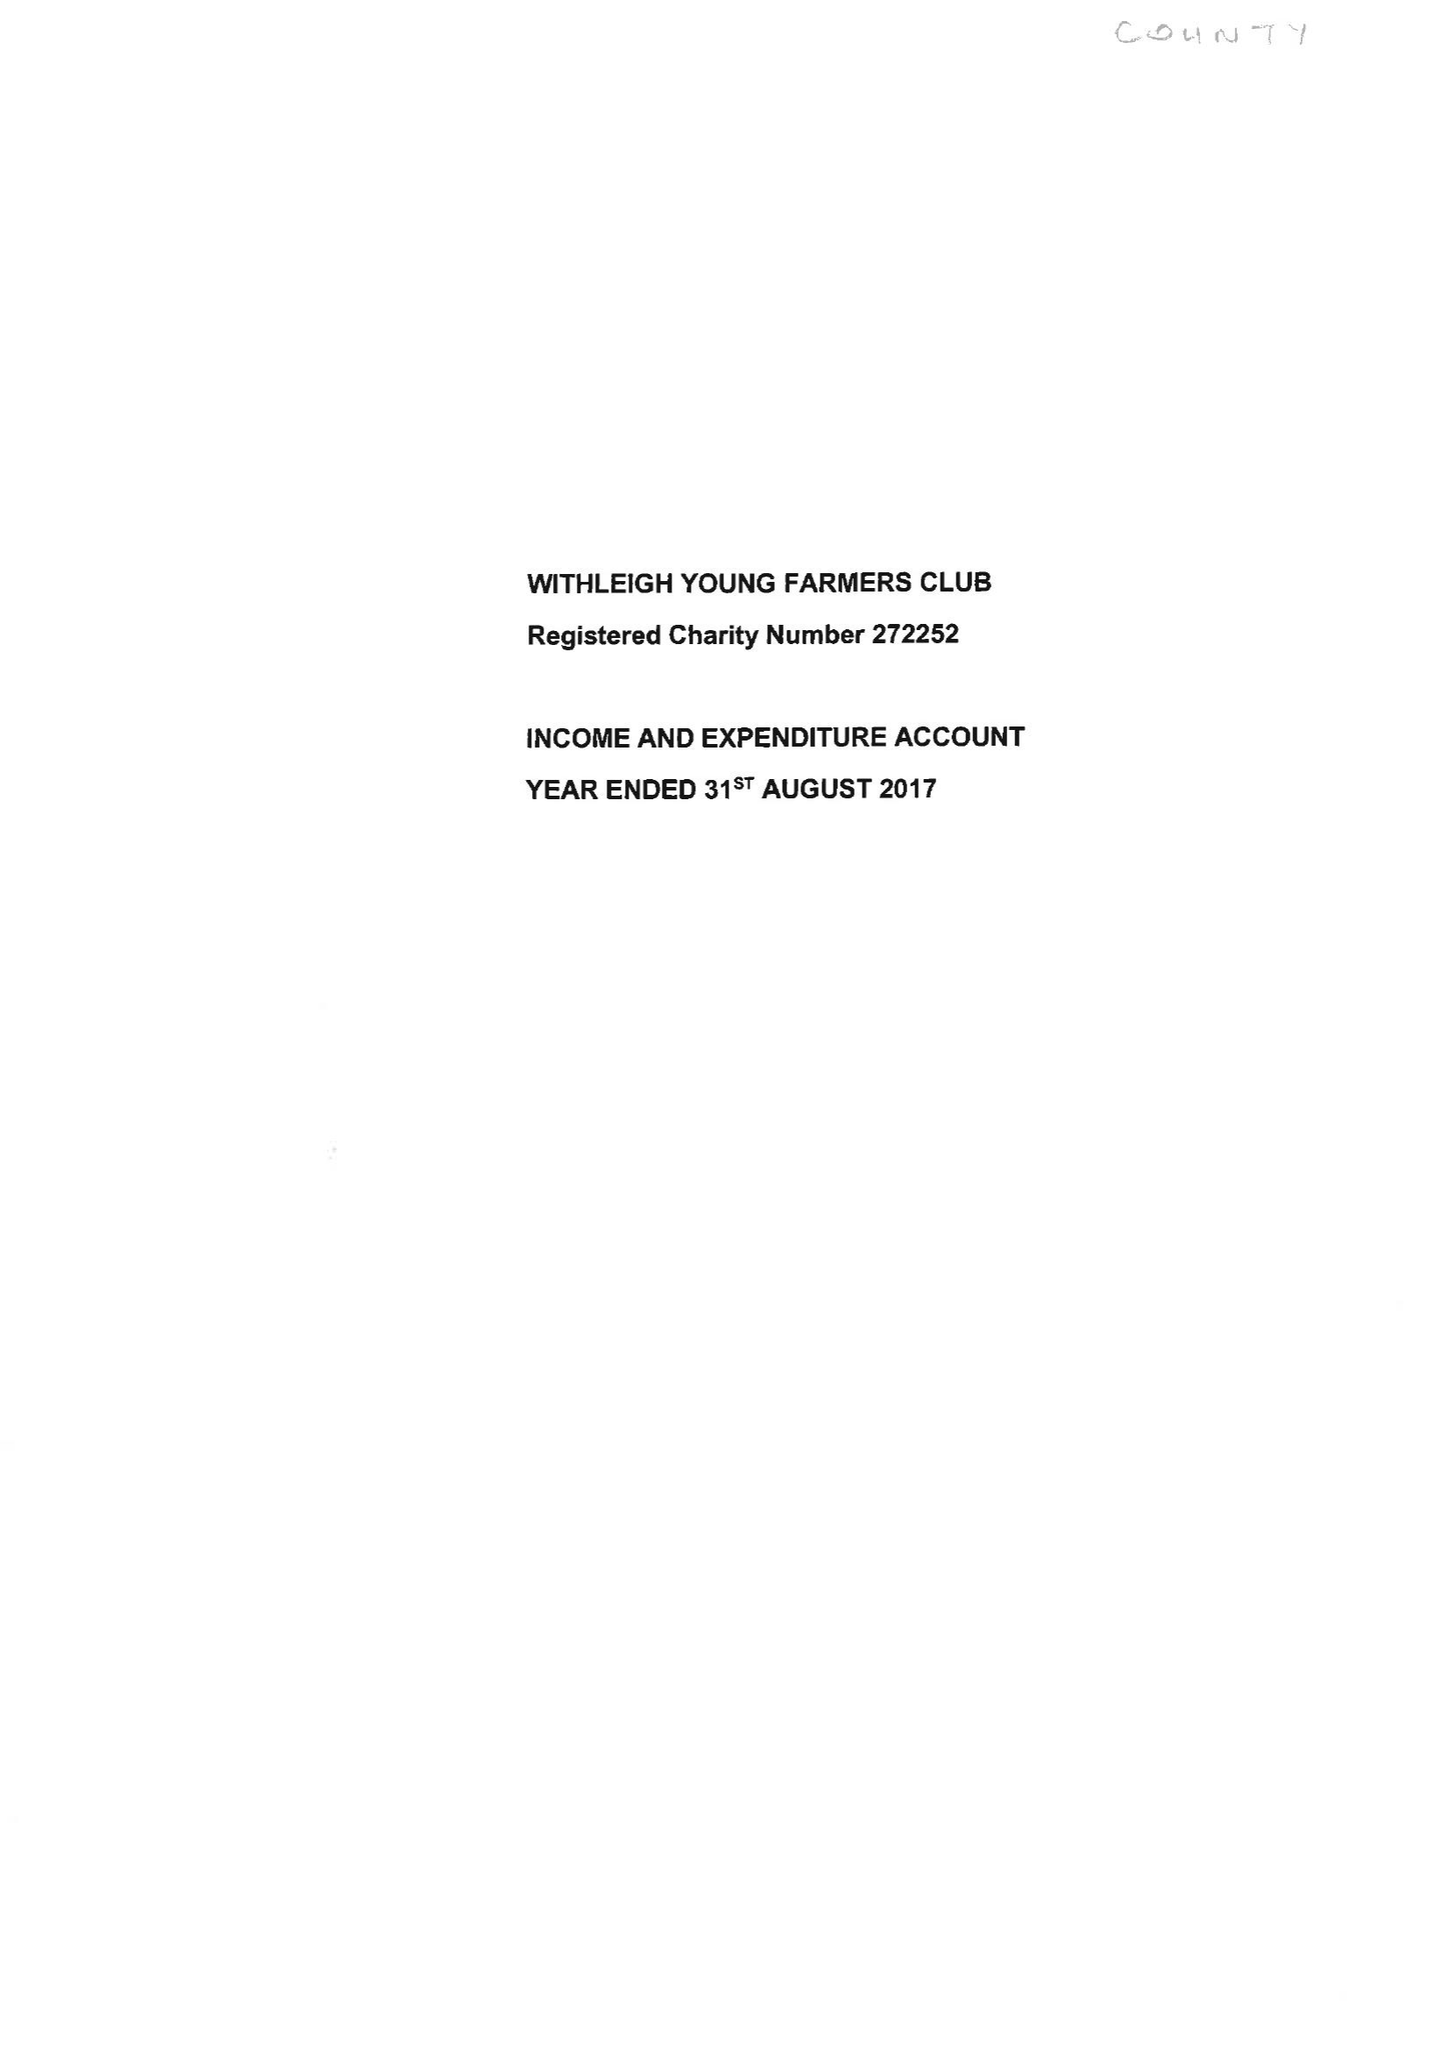What is the value for the report_date?
Answer the question using a single word or phrase. 2017-08-31 